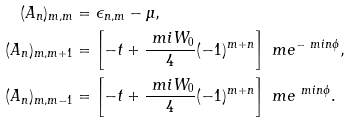Convert formula to latex. <formula><loc_0><loc_0><loc_500><loc_500>( A _ { n } ) _ { m , m } & = \epsilon _ { n , m } - \mu , \\ ( A _ { n } ) _ { m , m + 1 } & = \left [ - t + \frac { \ m i W _ { 0 } } { 4 } ( - 1 ) ^ { m + n } \right ] \ m e ^ { - \ m i n \phi } , \\ ( A _ { n } ) _ { m , m - 1 } & = \left [ - t + \frac { \ m i W _ { 0 } } { 4 } ( - 1 ) ^ { m + n } \right ] \ m e ^ { \ m i n \phi } .</formula> 